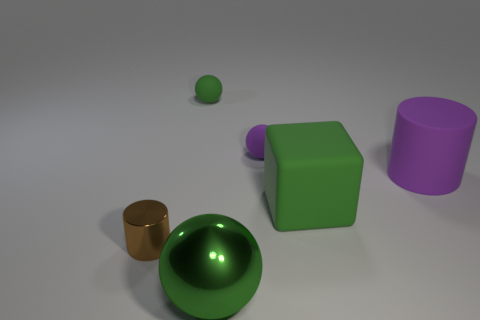There is a shiny thing that is on the right side of the metallic cylinder; does it have the same shape as the tiny thing that is in front of the big rubber block?
Make the answer very short. No. Are there any big yellow spheres made of the same material as the tiny green object?
Your response must be concise. No. What color is the metal thing in front of the cylinder in front of the purple thing that is right of the big cube?
Ensure brevity in your answer.  Green. Are the purple thing behind the purple rubber cylinder and the cylinder that is left of the big matte cube made of the same material?
Ensure brevity in your answer.  No. There is a metallic thing that is to the left of the tiny green sphere; what shape is it?
Provide a succinct answer. Cylinder. What number of objects are either matte blocks or tiny green matte things that are on the left side of the green shiny ball?
Offer a very short reply. 2. Is the material of the big cube the same as the big ball?
Ensure brevity in your answer.  No. Are there an equal number of small shiny cylinders in front of the green shiny thing and shiny objects that are in front of the metal cylinder?
Provide a short and direct response. No. There is a purple cylinder; what number of green rubber things are in front of it?
Ensure brevity in your answer.  1. How many things are either blue cylinders or tiny brown metal cylinders?
Your response must be concise. 1. 